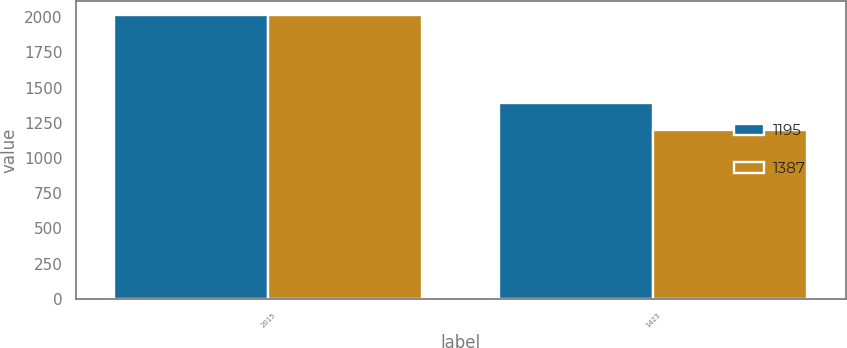Convert chart to OTSL. <chart><loc_0><loc_0><loc_500><loc_500><stacked_bar_chart><ecel><fcel>2015<fcel>1423<nl><fcel>1195<fcel>2014<fcel>1387<nl><fcel>1387<fcel>2013<fcel>1195<nl></chart> 